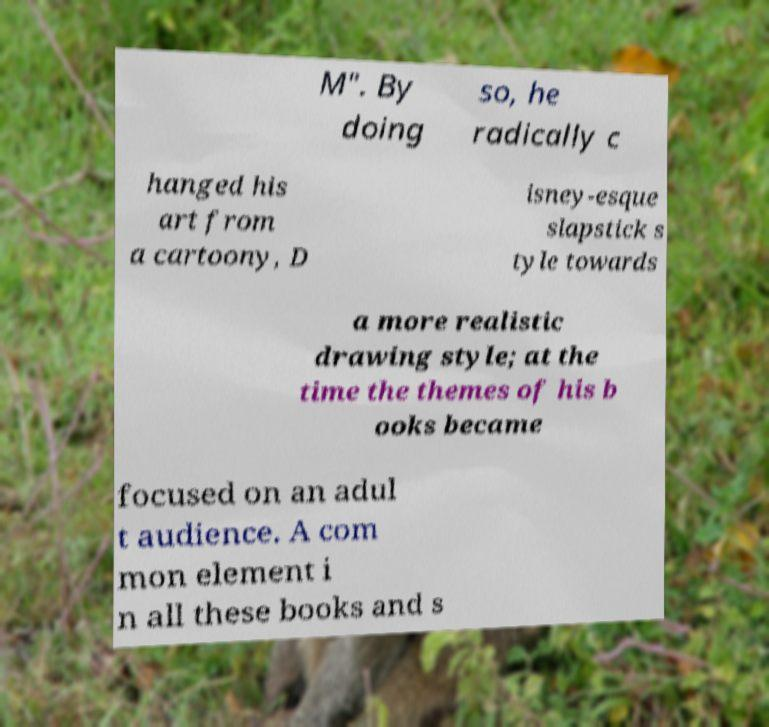For documentation purposes, I need the text within this image transcribed. Could you provide that? M". By doing so, he radically c hanged his art from a cartoony, D isney-esque slapstick s tyle towards a more realistic drawing style; at the time the themes of his b ooks became focused on an adul t audience. A com mon element i n all these books and s 